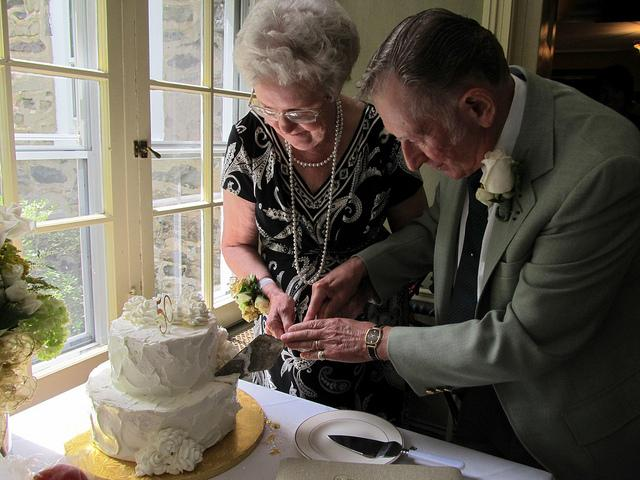Which occasion is this for?

Choices:
A) birthday
B) anniversary
C) christmas
D) easter anniversary 